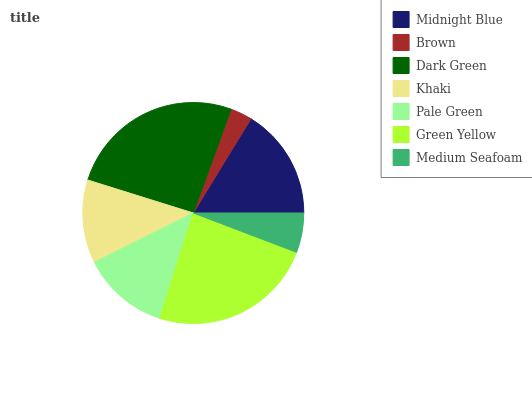Is Brown the minimum?
Answer yes or no. Yes. Is Dark Green the maximum?
Answer yes or no. Yes. Is Dark Green the minimum?
Answer yes or no. No. Is Brown the maximum?
Answer yes or no. No. Is Dark Green greater than Brown?
Answer yes or no. Yes. Is Brown less than Dark Green?
Answer yes or no. Yes. Is Brown greater than Dark Green?
Answer yes or no. No. Is Dark Green less than Brown?
Answer yes or no. No. Is Pale Green the high median?
Answer yes or no. Yes. Is Pale Green the low median?
Answer yes or no. Yes. Is Brown the high median?
Answer yes or no. No. Is Green Yellow the low median?
Answer yes or no. No. 